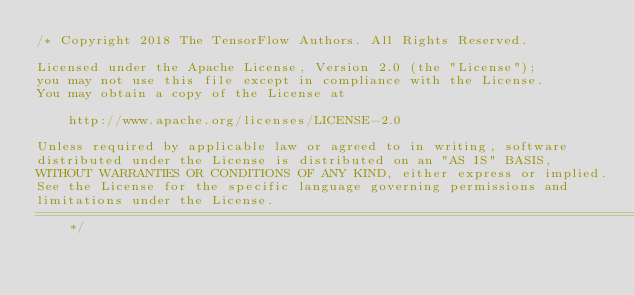Convert code to text. <code><loc_0><loc_0><loc_500><loc_500><_C_>/* Copyright 2018 The TensorFlow Authors. All Rights Reserved.

Licensed under the Apache License, Version 2.0 (the "License");
you may not use this file except in compliance with the License.
You may obtain a copy of the License at

    http://www.apache.org/licenses/LICENSE-2.0

Unless required by applicable law or agreed to in writing, software
distributed under the License is distributed on an "AS IS" BASIS,
WITHOUT WARRANTIES OR CONDITIONS OF ANY KIND, either express or implied.
See the License for the specific language governing permissions and
limitations under the License.
==============================================================================*/
</code> 